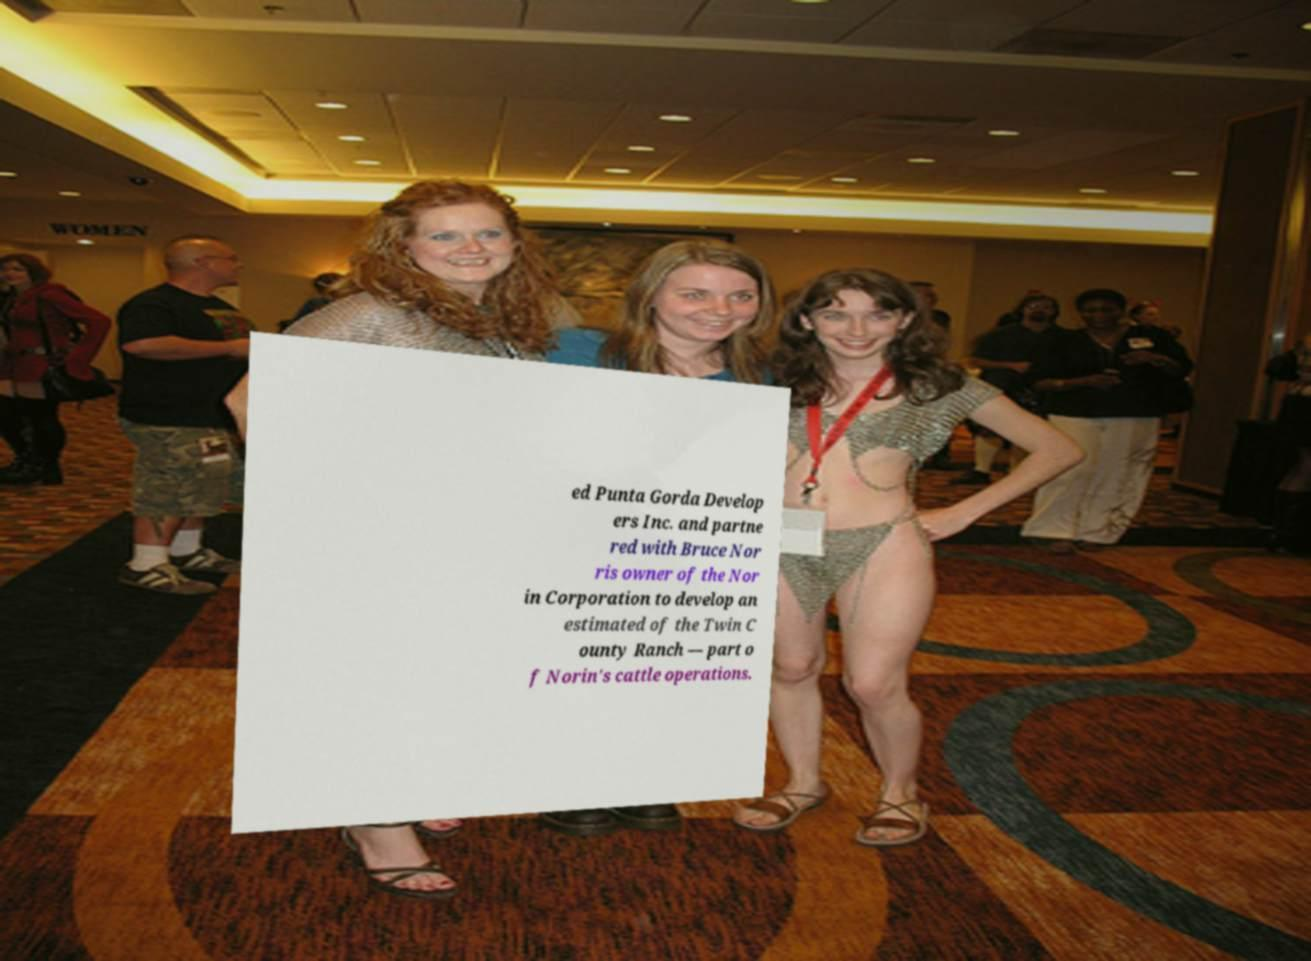What messages or text are displayed in this image? I need them in a readable, typed format. ed Punta Gorda Develop ers Inc. and partne red with Bruce Nor ris owner of the Nor in Corporation to develop an estimated of the Twin C ounty Ranch — part o f Norin's cattle operations. 